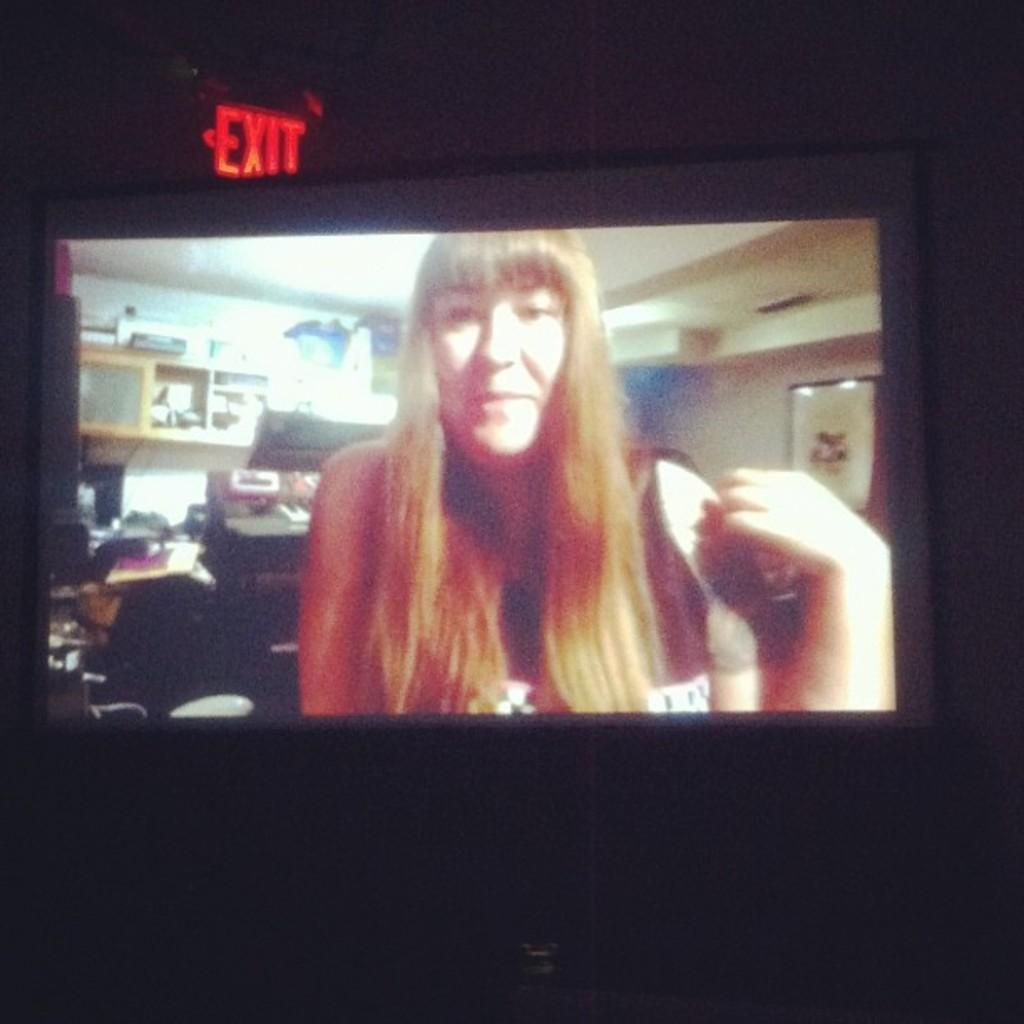<image>
Write a terse but informative summary of the picture. A woman with long hair and an Exit sign in red 